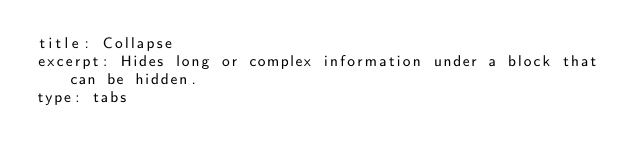<code> <loc_0><loc_0><loc_500><loc_500><_YAML_>title: Collapse
excerpt: Hides long or complex information under a block that can be hidden.
type: tabs
</code> 